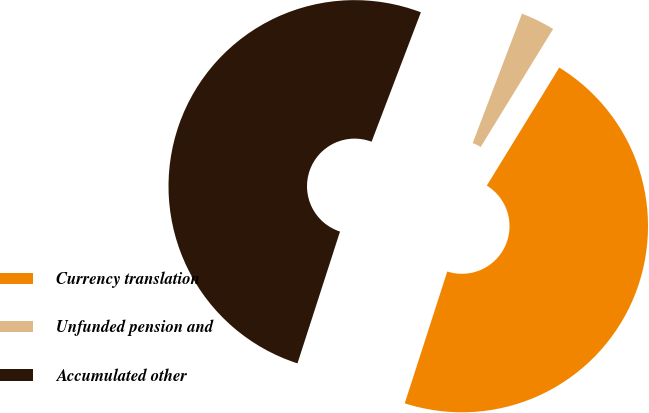<chart> <loc_0><loc_0><loc_500><loc_500><pie_chart><fcel>Currency translation<fcel>Unfunded pension and<fcel>Accumulated other<nl><fcel>46.21%<fcel>2.97%<fcel>50.83%<nl></chart> 